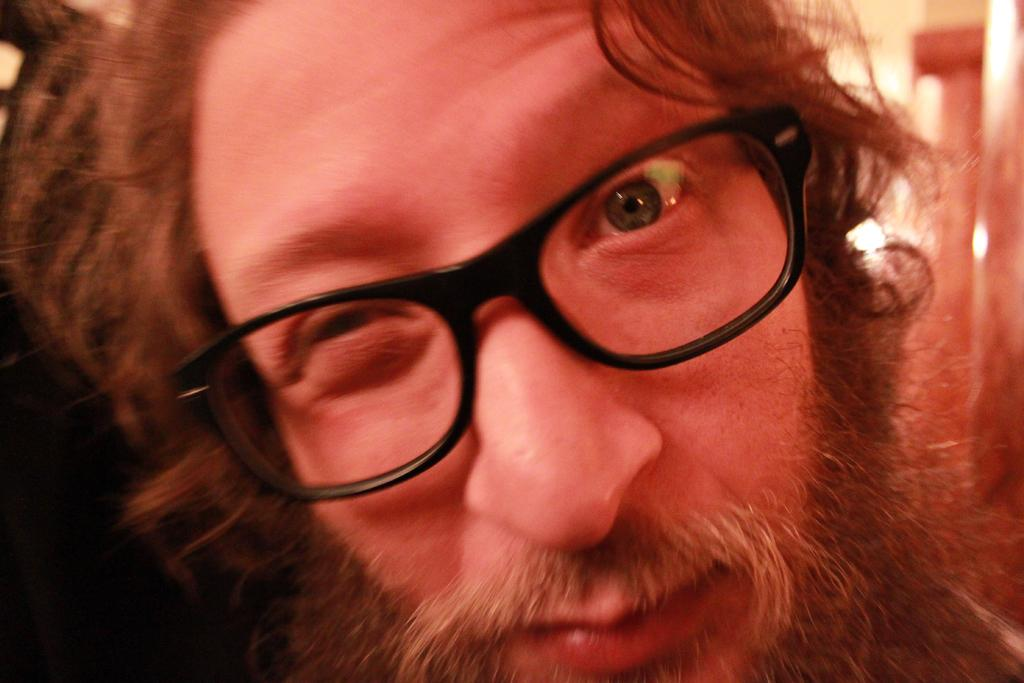Who is the main subject in the image? There is a person in the center of the image. What accessory is the person wearing? The person is wearing glasses. What can be seen behind the person in the image? There is a wall in the background of the image. How many cobwebs are visible on the wall behind the person in the image? There is no mention of cobwebs in the image, so it is impossible to determine their presence or quantity. 